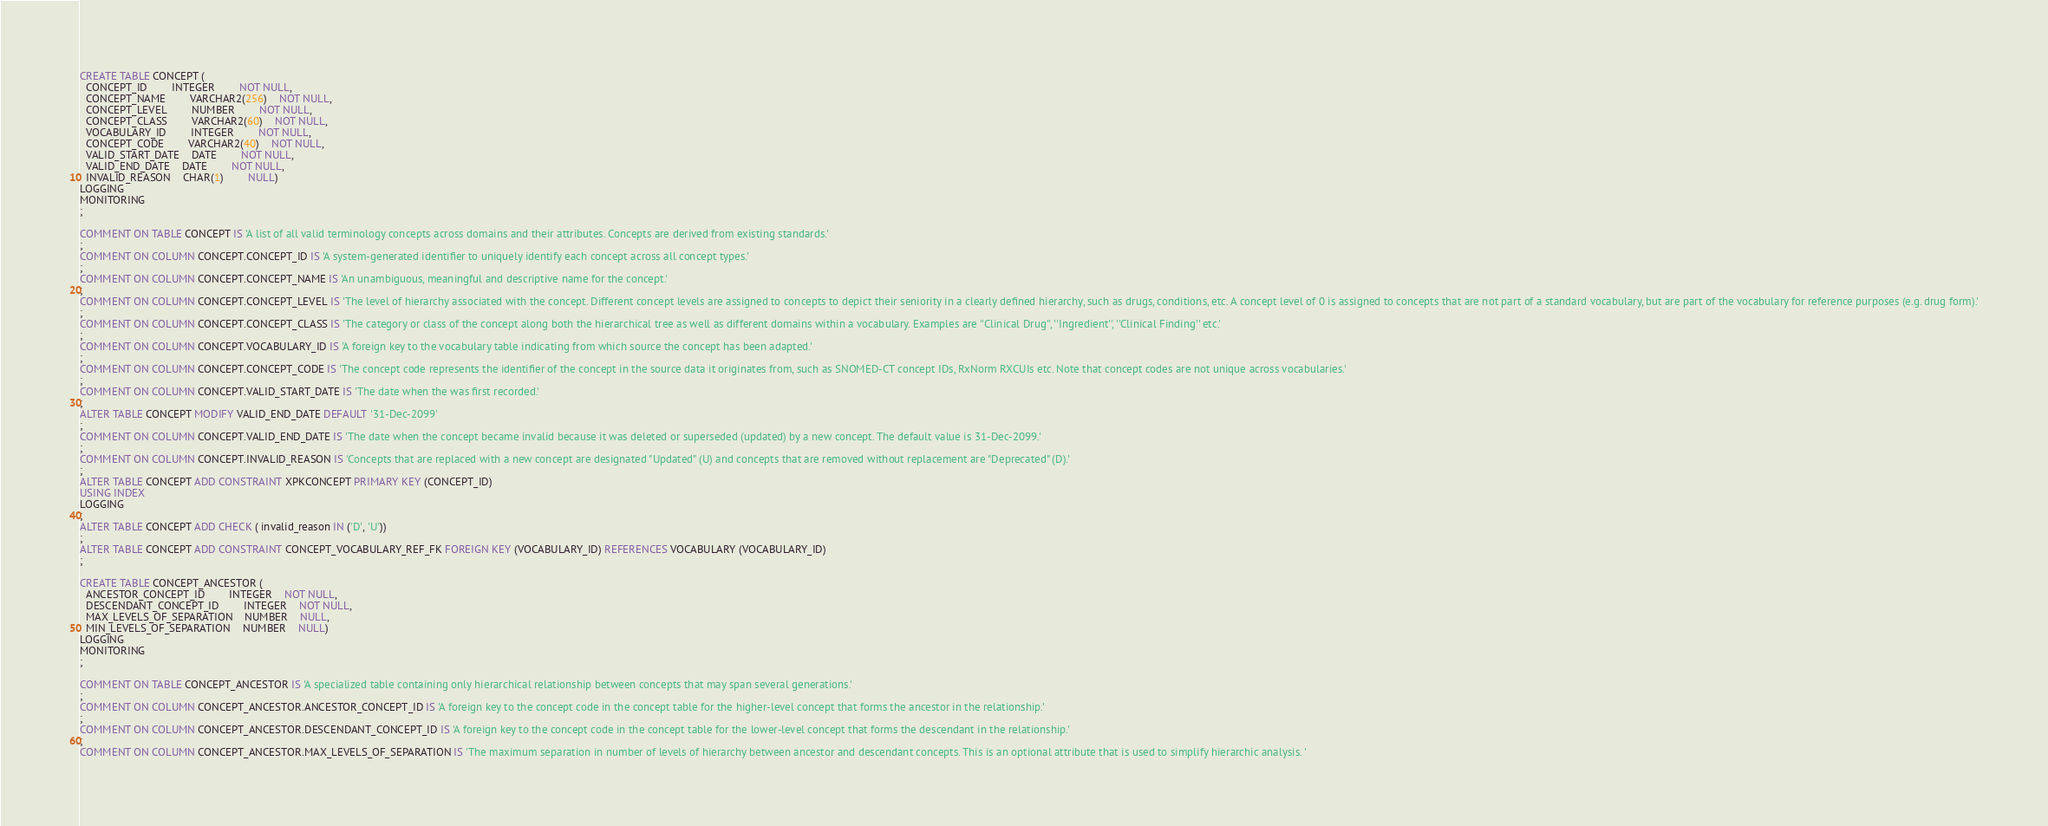Convert code to text. <code><loc_0><loc_0><loc_500><loc_500><_SQL_>CREATE TABLE CONCEPT (
  CONCEPT_ID		INTEGER		NOT NULL,
  CONCEPT_NAME		VARCHAR2(256)	NOT NULL,
  CONCEPT_LEVEL		NUMBER		NOT NULL,
  CONCEPT_CLASS		VARCHAR2(60)	NOT NULL,
  VOCABULARY_ID		INTEGER		NOT NULL,
  CONCEPT_CODE		VARCHAR2(40)	NOT NULL,
  VALID_START_DATE	DATE		NOT NULL,
  VALID_END_DATE	DATE		NOT NULL,
  INVALID_REASON	CHAR(1)		NULL)
LOGGING
MONITORING
;

COMMENT ON TABLE CONCEPT IS 'A list of all valid terminology concepts across domains and their attributes. Concepts are derived from existing standards.'
;
COMMENT ON COLUMN CONCEPT.CONCEPT_ID IS 'A system-generated identifier to uniquely identify each concept across all concept types.'
;
COMMENT ON COLUMN CONCEPT.CONCEPT_NAME IS 'An unambiguous, meaningful and descriptive name for the concept.'
;
COMMENT ON COLUMN CONCEPT.CONCEPT_LEVEL IS 'The level of hierarchy associated with the concept. Different concept levels are assigned to concepts to depict their seniority in a clearly defined hierarchy, such as drugs, conditions, etc. A concept level of 0 is assigned to concepts that are not part of a standard vocabulary, but are part of the vocabulary for reference purposes (e.g. drug form).'
;
COMMENT ON COLUMN CONCEPT.CONCEPT_CLASS IS 'The category or class of the concept along both the hierarchical tree as well as different domains within a vocabulary. Examples are ''Clinical Drug'', ''Ingredient'', ''Clinical Finding'' etc.'
;
COMMENT ON COLUMN CONCEPT.VOCABULARY_ID IS 'A foreign key to the vocabulary table indicating from which source the concept has been adapted.'
;
COMMENT ON COLUMN CONCEPT.CONCEPT_CODE IS 'The concept code represents the identifier of the concept in the source data it originates from, such as SNOMED-CT concept IDs, RxNorm RXCUIs etc. Note that concept codes are not unique across vocabularies.'
;
COMMENT ON COLUMN CONCEPT.VALID_START_DATE IS 'The date when the was first recorded.'
;
ALTER TABLE CONCEPT MODIFY VALID_END_DATE DEFAULT '31-Dec-2099'
;
COMMENT ON COLUMN CONCEPT.VALID_END_DATE IS 'The date when the concept became invalid because it was deleted or superseded (updated) by a new concept. The default value is 31-Dec-2099.'
;
COMMENT ON COLUMN CONCEPT.INVALID_REASON IS 'Concepts that are replaced with a new concept are designated "Updated" (U) and concepts that are removed without replacement are "Deprecated" (D).'
;
ALTER TABLE CONCEPT ADD CONSTRAINT XPKCONCEPT PRIMARY KEY (CONCEPT_ID)
USING INDEX
LOGGING
;
ALTER TABLE CONCEPT ADD CHECK ( invalid_reason IN ('D', 'U'))
;
ALTER TABLE CONCEPT ADD CONSTRAINT CONCEPT_VOCABULARY_REF_FK FOREIGN KEY (VOCABULARY_ID) REFERENCES VOCABULARY (VOCABULARY_ID)
;

CREATE TABLE CONCEPT_ANCESTOR (
  ANCESTOR_CONCEPT_ID		INTEGER	NOT NULL,
  DESCENDANT_CONCEPT_ID		INTEGER	NOT NULL,
  MAX_LEVELS_OF_SEPARATION	NUMBER	NULL,
  MIN_LEVELS_OF_SEPARATION	NUMBER	NULL)
LOGGING
MONITORING
;

COMMENT ON TABLE CONCEPT_ANCESTOR IS 'A specialized table containing only hierarchical relationship between concepts that may span several generations.'
;
COMMENT ON COLUMN CONCEPT_ANCESTOR.ANCESTOR_CONCEPT_ID IS 'A foreign key to the concept code in the concept table for the higher-level concept that forms the ancestor in the relationship.'
;
COMMENT ON COLUMN CONCEPT_ANCESTOR.DESCENDANT_CONCEPT_ID IS 'A foreign key to the concept code in the concept table for the lower-level concept that forms the descendant in the relationship.'
;
COMMENT ON COLUMN CONCEPT_ANCESTOR.MAX_LEVELS_OF_SEPARATION IS 'The maximum separation in number of levels of hierarchy between ancestor and descendant concepts. This is an optional attribute that is used to simplify hierarchic analysis. '</code> 